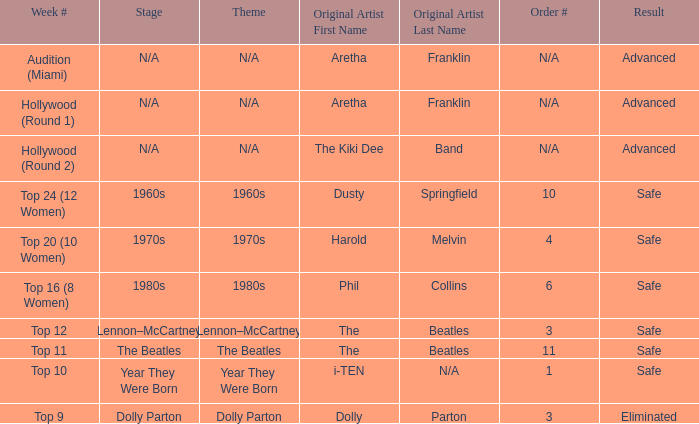What is the order number that has top 20 (10 women)  as the week number? 4.0. 